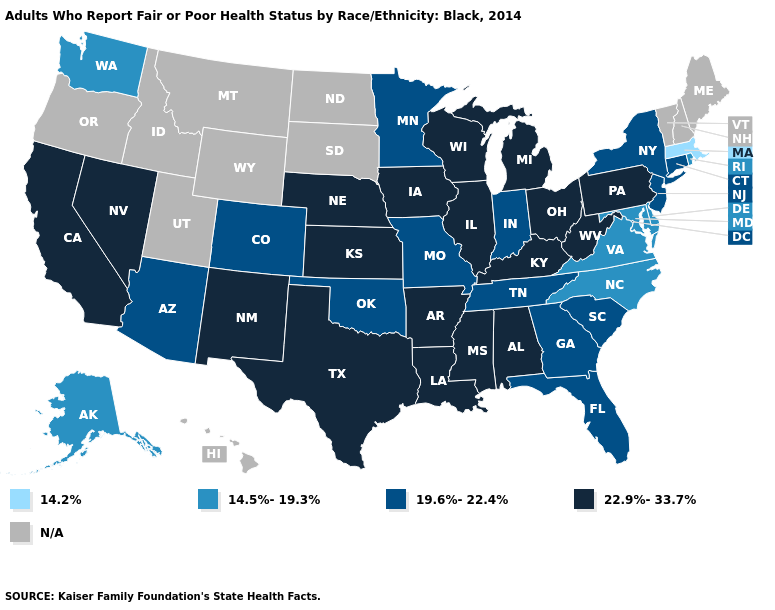Name the states that have a value in the range 14.5%-19.3%?
Concise answer only. Alaska, Delaware, Maryland, North Carolina, Rhode Island, Virginia, Washington. What is the value of North Dakota?
Short answer required. N/A. Among the states that border Wyoming , does Nebraska have the highest value?
Be succinct. Yes. Name the states that have a value in the range 14.2%?
Keep it brief. Massachusetts. Does Ohio have the lowest value in the MidWest?
Write a very short answer. No. What is the highest value in the USA?
Give a very brief answer. 22.9%-33.7%. Does Massachusetts have the lowest value in the USA?
Quick response, please. Yes. Does the first symbol in the legend represent the smallest category?
Give a very brief answer. Yes. Name the states that have a value in the range 14.2%?
Write a very short answer. Massachusetts. Among the states that border Iowa , which have the lowest value?
Quick response, please. Minnesota, Missouri. Name the states that have a value in the range N/A?
Write a very short answer. Hawaii, Idaho, Maine, Montana, New Hampshire, North Dakota, Oregon, South Dakota, Utah, Vermont, Wyoming. What is the value of Connecticut?
Keep it brief. 19.6%-22.4%. 